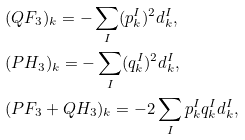Convert formula to latex. <formula><loc_0><loc_0><loc_500><loc_500>& ( Q F _ { 3 } ) _ { k } = - \sum _ { I } ( p _ { k } ^ { I } ) ^ { 2 } d _ { k } ^ { I } , \\ & ( P H _ { 3 } ) _ { k } = - \sum _ { I } ( q _ { k } ^ { I } ) ^ { 2 } d _ { k } ^ { I } , \\ & ( P F _ { 3 } + Q H _ { 3 } ) _ { k } = - 2 \sum _ { I } p _ { k } ^ { I } q _ { k } ^ { I } d _ { k } ^ { I } ,</formula> 